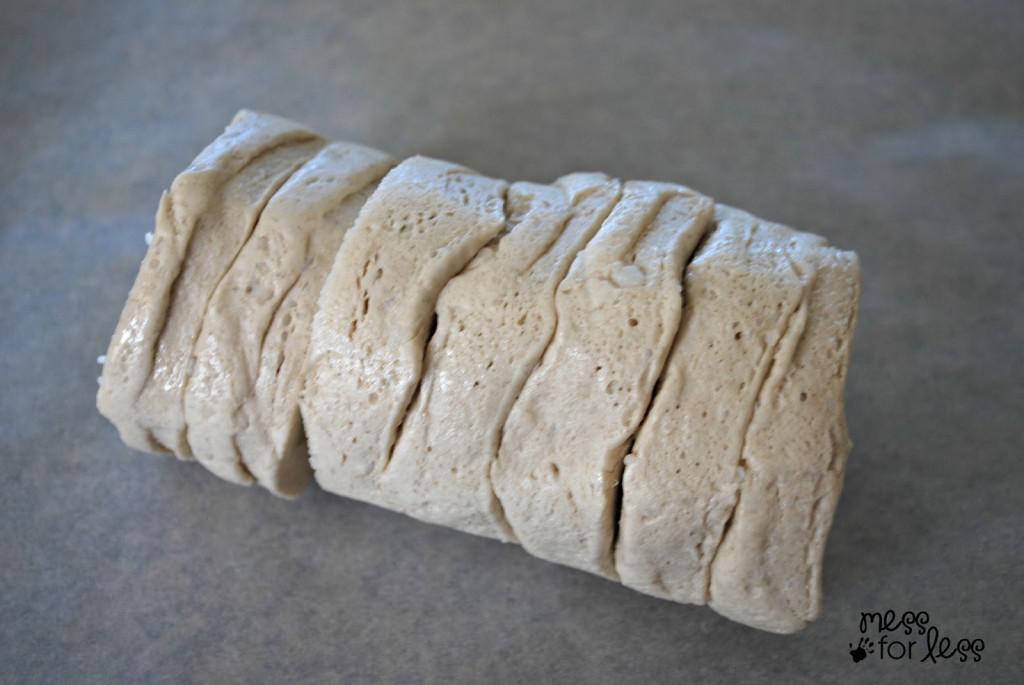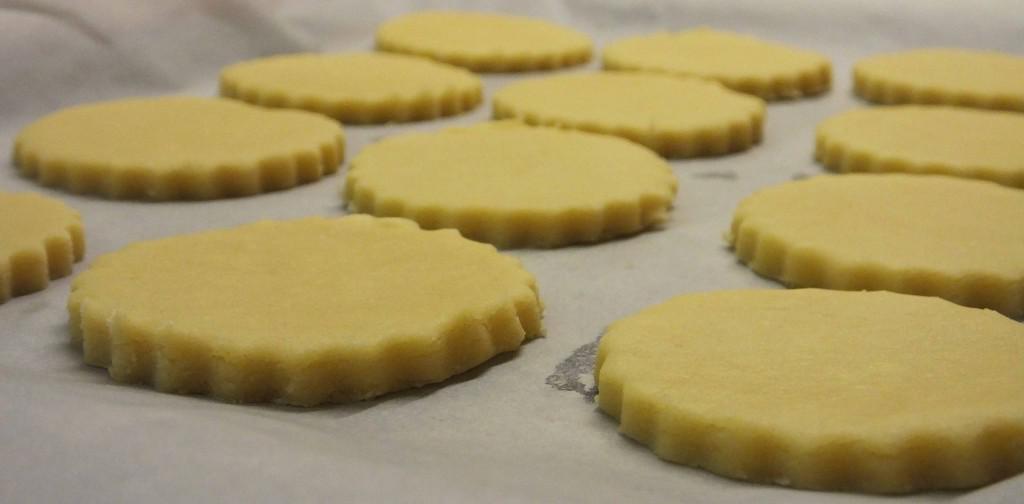The first image is the image on the left, the second image is the image on the right. Evaluate the accuracy of this statement regarding the images: "Some dough is shaped like a cylinder.". Is it true? Answer yes or no. Yes. The first image is the image on the left, the second image is the image on the right. For the images shown, is this caption "The dough in at least one image is still in a round biscuit can shape." true? Answer yes or no. Yes. 